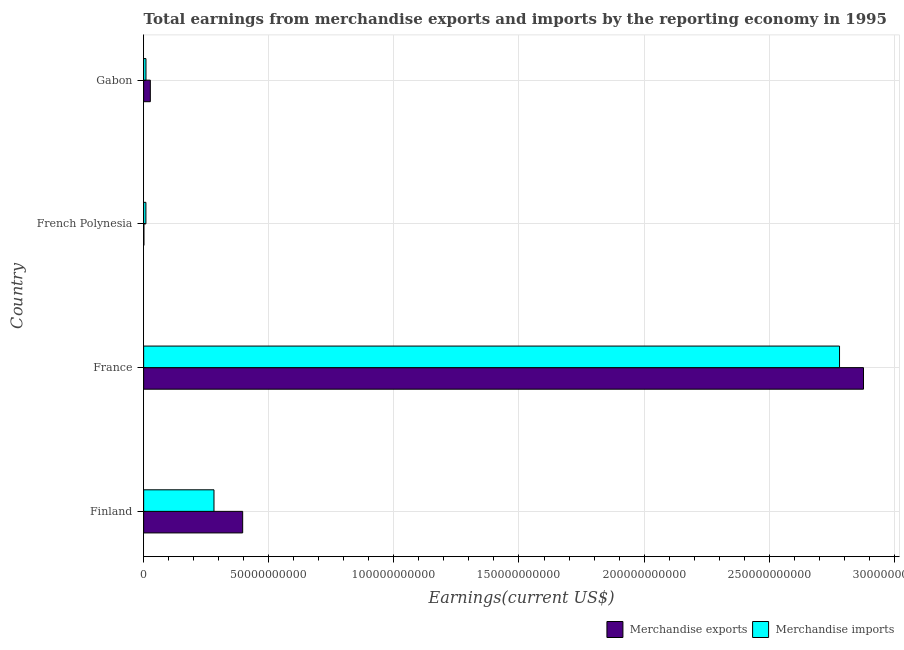How many different coloured bars are there?
Provide a short and direct response. 2. Are the number of bars on each tick of the Y-axis equal?
Provide a succinct answer. Yes. How many bars are there on the 1st tick from the top?
Your response must be concise. 2. How many bars are there on the 3rd tick from the bottom?
Your answer should be compact. 2. In how many cases, is the number of bars for a given country not equal to the number of legend labels?
Provide a succinct answer. 0. What is the earnings from merchandise imports in French Polynesia?
Give a very brief answer. 9.05e+08. Across all countries, what is the maximum earnings from merchandise exports?
Offer a terse response. 2.88e+11. Across all countries, what is the minimum earnings from merchandise imports?
Offer a terse response. 9.05e+08. In which country was the earnings from merchandise exports minimum?
Your answer should be very brief. French Polynesia. What is the total earnings from merchandise imports in the graph?
Your response must be concise. 3.08e+11. What is the difference between the earnings from merchandise imports in France and that in Gabon?
Keep it short and to the point. 2.77e+11. What is the difference between the earnings from merchandise exports in Gabon and the earnings from merchandise imports in France?
Make the answer very short. -2.75e+11. What is the average earnings from merchandise exports per country?
Offer a very short reply. 8.25e+1. What is the difference between the earnings from merchandise imports and earnings from merchandise exports in Finland?
Give a very brief answer. -1.15e+1. In how many countries, is the earnings from merchandise imports greater than 210000000000 US$?
Your answer should be compact. 1. What is the ratio of the earnings from merchandise exports in Finland to that in Gabon?
Offer a terse response. 14.82. Is the difference between the earnings from merchandise exports in France and Gabon greater than the difference between the earnings from merchandise imports in France and Gabon?
Offer a terse response. Yes. What is the difference between the highest and the second highest earnings from merchandise imports?
Ensure brevity in your answer.  2.50e+11. What is the difference between the highest and the lowest earnings from merchandise imports?
Offer a very short reply. 2.77e+11. Is the sum of the earnings from merchandise imports in Finland and French Polynesia greater than the maximum earnings from merchandise exports across all countries?
Give a very brief answer. No. What does the 2nd bar from the top in France represents?
Provide a succinct answer. Merchandise exports. What does the 2nd bar from the bottom in France represents?
Give a very brief answer. Merchandise imports. Are all the bars in the graph horizontal?
Give a very brief answer. Yes. What is the difference between two consecutive major ticks on the X-axis?
Provide a succinct answer. 5.00e+1. Does the graph contain grids?
Provide a succinct answer. Yes. Where does the legend appear in the graph?
Offer a terse response. Bottom right. What is the title of the graph?
Provide a short and direct response. Total earnings from merchandise exports and imports by the reporting economy in 1995. Does "Primary school" appear as one of the legend labels in the graph?
Your answer should be compact. No. What is the label or title of the X-axis?
Offer a very short reply. Earnings(current US$). What is the label or title of the Y-axis?
Make the answer very short. Country. What is the Earnings(current US$) of Merchandise exports in Finland?
Offer a very short reply. 3.96e+1. What is the Earnings(current US$) in Merchandise imports in Finland?
Provide a succinct answer. 2.81e+1. What is the Earnings(current US$) of Merchandise exports in France?
Offer a very short reply. 2.88e+11. What is the Earnings(current US$) of Merchandise imports in France?
Ensure brevity in your answer.  2.78e+11. What is the Earnings(current US$) of Merchandise exports in French Polynesia?
Your answer should be compact. 1.05e+08. What is the Earnings(current US$) of Merchandise imports in French Polynesia?
Provide a short and direct response. 9.05e+08. What is the Earnings(current US$) in Merchandise exports in Gabon?
Make the answer very short. 2.67e+09. What is the Earnings(current US$) in Merchandise imports in Gabon?
Give a very brief answer. 9.30e+08. Across all countries, what is the maximum Earnings(current US$) in Merchandise exports?
Provide a succinct answer. 2.88e+11. Across all countries, what is the maximum Earnings(current US$) in Merchandise imports?
Provide a succinct answer. 2.78e+11. Across all countries, what is the minimum Earnings(current US$) of Merchandise exports?
Your answer should be very brief. 1.05e+08. Across all countries, what is the minimum Earnings(current US$) of Merchandise imports?
Ensure brevity in your answer.  9.05e+08. What is the total Earnings(current US$) in Merchandise exports in the graph?
Your answer should be very brief. 3.30e+11. What is the total Earnings(current US$) of Merchandise imports in the graph?
Offer a terse response. 3.08e+11. What is the difference between the Earnings(current US$) of Merchandise exports in Finland and that in France?
Your answer should be compact. -2.48e+11. What is the difference between the Earnings(current US$) of Merchandise imports in Finland and that in France?
Your response must be concise. -2.50e+11. What is the difference between the Earnings(current US$) in Merchandise exports in Finland and that in French Polynesia?
Make the answer very short. 3.95e+1. What is the difference between the Earnings(current US$) of Merchandise imports in Finland and that in French Polynesia?
Give a very brief answer. 2.72e+1. What is the difference between the Earnings(current US$) of Merchandise exports in Finland and that in Gabon?
Provide a succinct answer. 3.69e+1. What is the difference between the Earnings(current US$) in Merchandise imports in Finland and that in Gabon?
Provide a short and direct response. 2.72e+1. What is the difference between the Earnings(current US$) of Merchandise exports in France and that in French Polynesia?
Make the answer very short. 2.88e+11. What is the difference between the Earnings(current US$) of Merchandise imports in France and that in French Polynesia?
Provide a succinct answer. 2.77e+11. What is the difference between the Earnings(current US$) of Merchandise exports in France and that in Gabon?
Your response must be concise. 2.85e+11. What is the difference between the Earnings(current US$) of Merchandise imports in France and that in Gabon?
Make the answer very short. 2.77e+11. What is the difference between the Earnings(current US$) of Merchandise exports in French Polynesia and that in Gabon?
Provide a succinct answer. -2.57e+09. What is the difference between the Earnings(current US$) in Merchandise imports in French Polynesia and that in Gabon?
Provide a short and direct response. -2.52e+07. What is the difference between the Earnings(current US$) of Merchandise exports in Finland and the Earnings(current US$) of Merchandise imports in France?
Give a very brief answer. -2.39e+11. What is the difference between the Earnings(current US$) of Merchandise exports in Finland and the Earnings(current US$) of Merchandise imports in French Polynesia?
Provide a short and direct response. 3.87e+1. What is the difference between the Earnings(current US$) of Merchandise exports in Finland and the Earnings(current US$) of Merchandise imports in Gabon?
Offer a terse response. 3.86e+1. What is the difference between the Earnings(current US$) of Merchandise exports in France and the Earnings(current US$) of Merchandise imports in French Polynesia?
Ensure brevity in your answer.  2.87e+11. What is the difference between the Earnings(current US$) in Merchandise exports in France and the Earnings(current US$) in Merchandise imports in Gabon?
Offer a terse response. 2.87e+11. What is the difference between the Earnings(current US$) in Merchandise exports in French Polynesia and the Earnings(current US$) in Merchandise imports in Gabon?
Provide a short and direct response. -8.26e+08. What is the average Earnings(current US$) in Merchandise exports per country?
Keep it short and to the point. 8.25e+1. What is the average Earnings(current US$) in Merchandise imports per country?
Keep it short and to the point. 7.70e+1. What is the difference between the Earnings(current US$) of Merchandise exports and Earnings(current US$) of Merchandise imports in Finland?
Provide a succinct answer. 1.15e+1. What is the difference between the Earnings(current US$) of Merchandise exports and Earnings(current US$) of Merchandise imports in France?
Your answer should be compact. 9.58e+09. What is the difference between the Earnings(current US$) of Merchandise exports and Earnings(current US$) of Merchandise imports in French Polynesia?
Give a very brief answer. -8.00e+08. What is the difference between the Earnings(current US$) of Merchandise exports and Earnings(current US$) of Merchandise imports in Gabon?
Keep it short and to the point. 1.74e+09. What is the ratio of the Earnings(current US$) of Merchandise exports in Finland to that in France?
Provide a short and direct response. 0.14. What is the ratio of the Earnings(current US$) in Merchandise imports in Finland to that in France?
Give a very brief answer. 0.1. What is the ratio of the Earnings(current US$) in Merchandise exports in Finland to that in French Polynesia?
Offer a very short reply. 378.51. What is the ratio of the Earnings(current US$) of Merchandise imports in Finland to that in French Polynesia?
Give a very brief answer. 31.07. What is the ratio of the Earnings(current US$) in Merchandise exports in Finland to that in Gabon?
Your response must be concise. 14.82. What is the ratio of the Earnings(current US$) of Merchandise imports in Finland to that in Gabon?
Your answer should be very brief. 30.22. What is the ratio of the Earnings(current US$) in Merchandise exports in France to that in French Polynesia?
Keep it short and to the point. 2751.73. What is the ratio of the Earnings(current US$) of Merchandise imports in France to that in French Polynesia?
Your response must be concise. 307.32. What is the ratio of the Earnings(current US$) of Merchandise exports in France to that in Gabon?
Make the answer very short. 107.72. What is the ratio of the Earnings(current US$) of Merchandise imports in France to that in Gabon?
Provide a short and direct response. 298.99. What is the ratio of the Earnings(current US$) in Merchandise exports in French Polynesia to that in Gabon?
Make the answer very short. 0.04. What is the ratio of the Earnings(current US$) of Merchandise imports in French Polynesia to that in Gabon?
Your answer should be compact. 0.97. What is the difference between the highest and the second highest Earnings(current US$) of Merchandise exports?
Offer a very short reply. 2.48e+11. What is the difference between the highest and the second highest Earnings(current US$) of Merchandise imports?
Ensure brevity in your answer.  2.50e+11. What is the difference between the highest and the lowest Earnings(current US$) in Merchandise exports?
Your response must be concise. 2.88e+11. What is the difference between the highest and the lowest Earnings(current US$) of Merchandise imports?
Provide a succinct answer. 2.77e+11. 